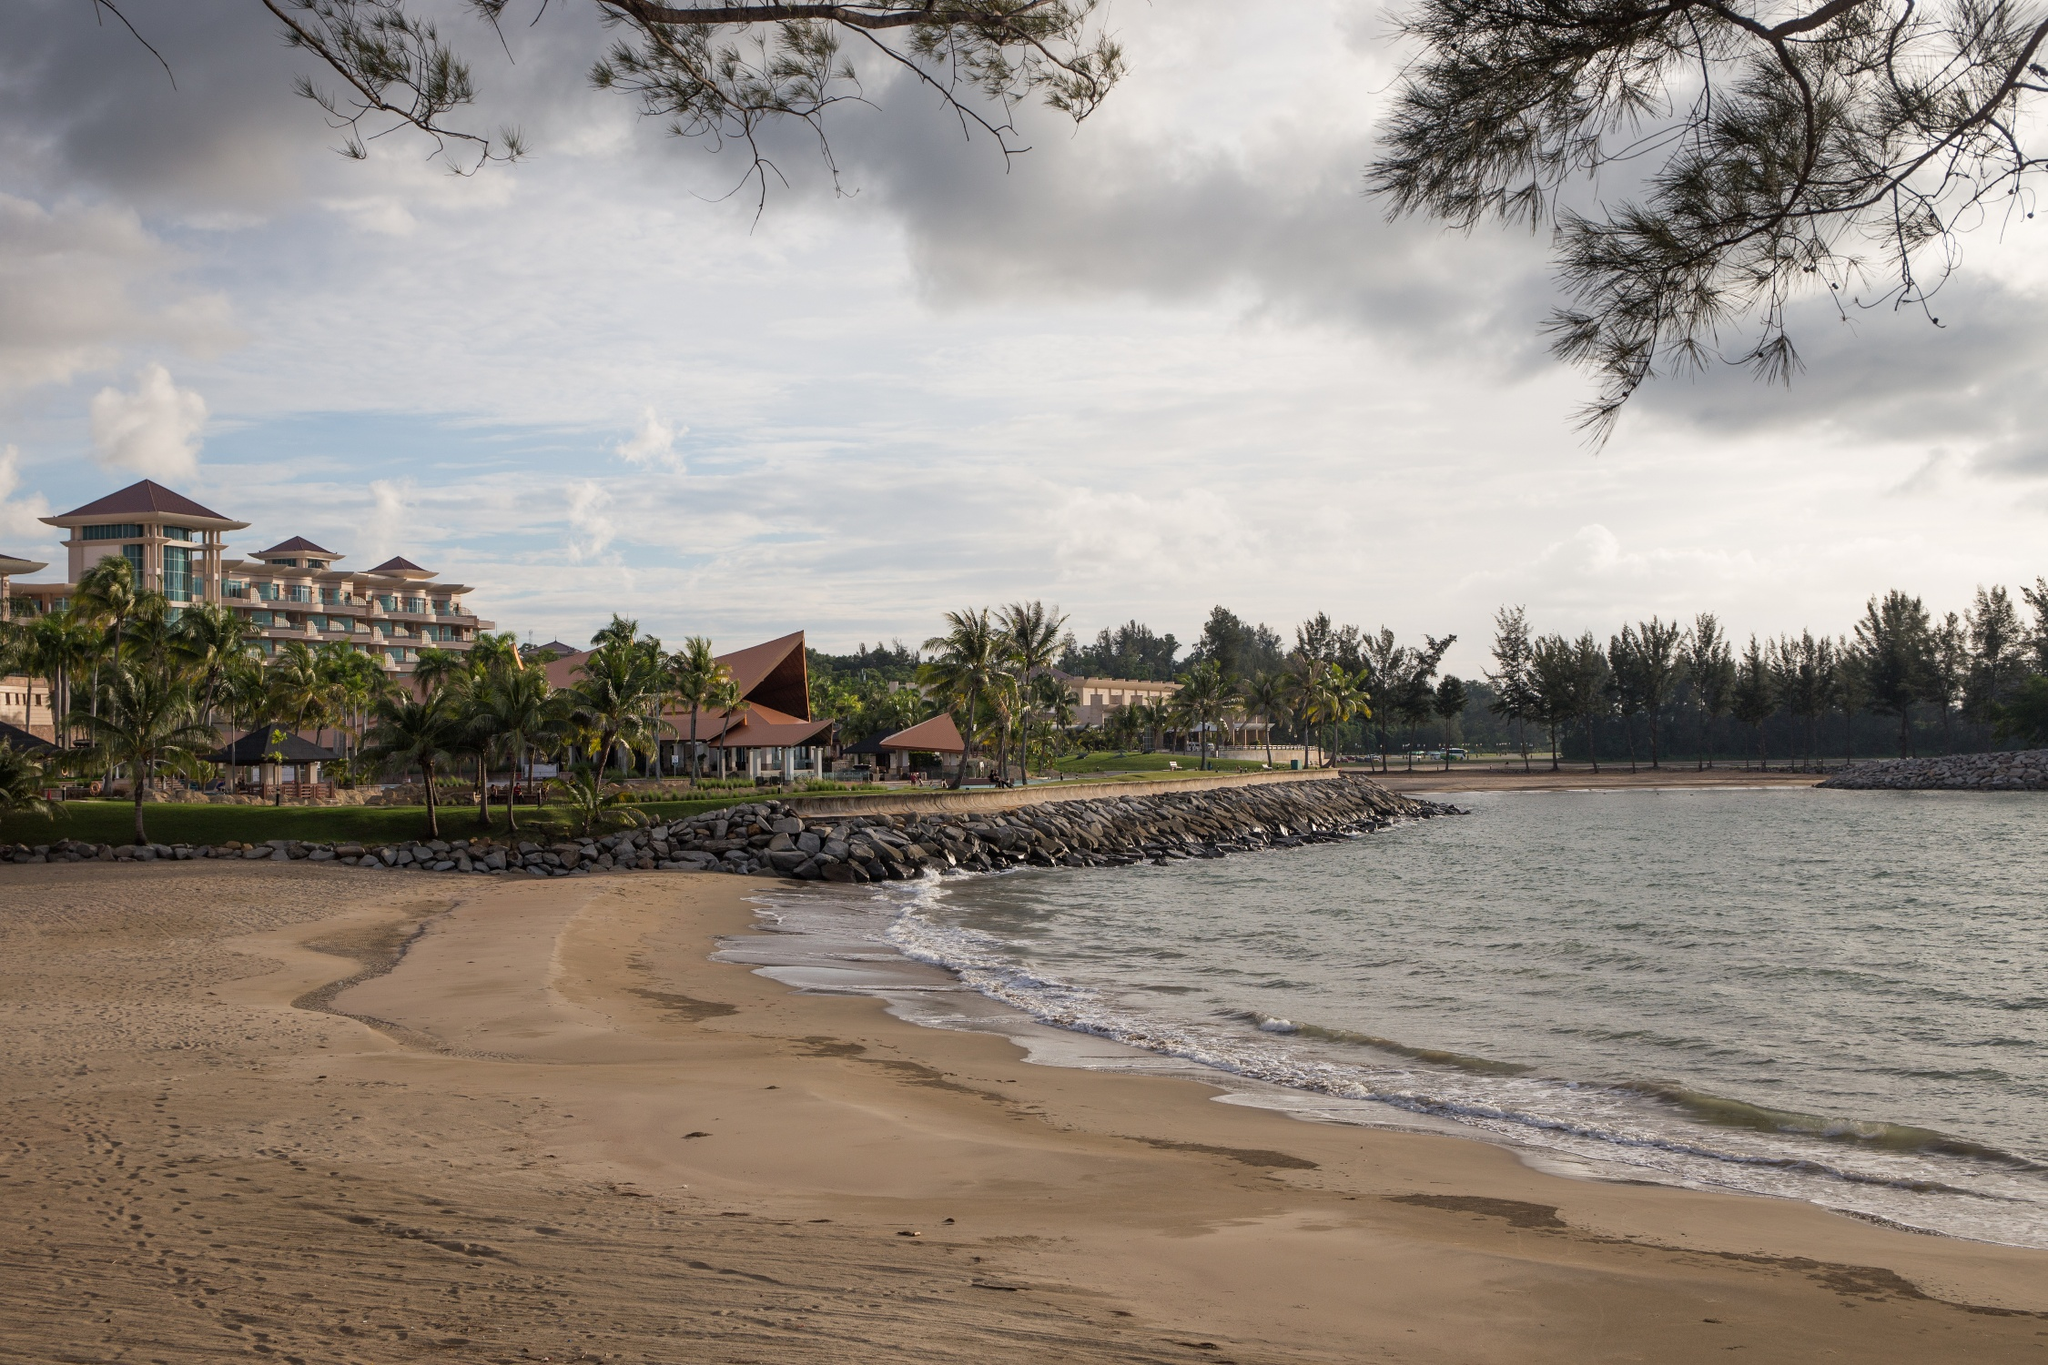Describe the activities one can do at this beach resort. This beach resort offers a host of activities designed to cater to a variety of interests. Guests can enjoy swimming in the tranquil ocean waters or lounging on the sandy shores under the shade of palm trees. For those who love adventure, there are options for water sports such as kayaking, paddle boarding, and jet skiing. The resort likely features a well-maintained swimming pool, perfect for a refreshing dip or for activities like water aerobics. Additionally, the scenic surroundings are ideal for nature walks or jogs along the beach, and the resort may have guided tours to explore the local flora and fauna. The presence of the beautifully landscaped gardens suggests that guests can indulge in peaceful strolls or find serene spots for yoga and meditation. Evening entertainment might include cultural performances or beach bonfires, providing a truly immersive and enjoyable stay. What kind of dining experiences could one expect at a resort like this? Guests at this beach resort can expect a delightful array of dining experiences that showcase both local and international flavors. The resort likely boasts multiple dining venues, from elegant restaurants offering fine dining to casual beachside cafes. Guests can savor fresh seafood specialties, perhaps even caught daily from the surrounding waters, prepared with local spices and herbs. The menu might also include tropical fruits and vegetables, adding vibrant flavors to each dish. For those who enjoy international cuisine, there may be themed nights featuring Italian, Japanese, or Mediterranean dishes, ensuring a diverse culinary journey. Dining with a view of the ocean, either during a romantic sunset dinner or a laid-back breakfast with the sound of waves, enhances the overall experience. Additionally, the resort might offer private dining experiences, allowing guests to enjoy a meal on the beach or in a secluded garden setting. Imagine if this beach resort was the setting for a movie. What genre would it be and why? This beach resort would make a perfect setting for a romantic drama or a feel-good romance movie. The stunning and tranquil scenery, with its sandy beaches, clear waters, and lush greenery, sets an ideal backdrop for a story of love and personal discovery. The resort's luxurious amenities and picturesque locations—such as private beach dinners, scenic walks, and sunset views—add to the romantic atmosphere of the film. The architectural beauty of the resort combined with the natural surroundings creates a versatile set that could also accommodate moments of drama, introspection, and emotional growth. Alternatively, it could serve as a hidden gem in a thrilling adventure film, where the serene setting contrasts with the excitement of an unfolding treasure hunt or a mission filled with twists and turns. 